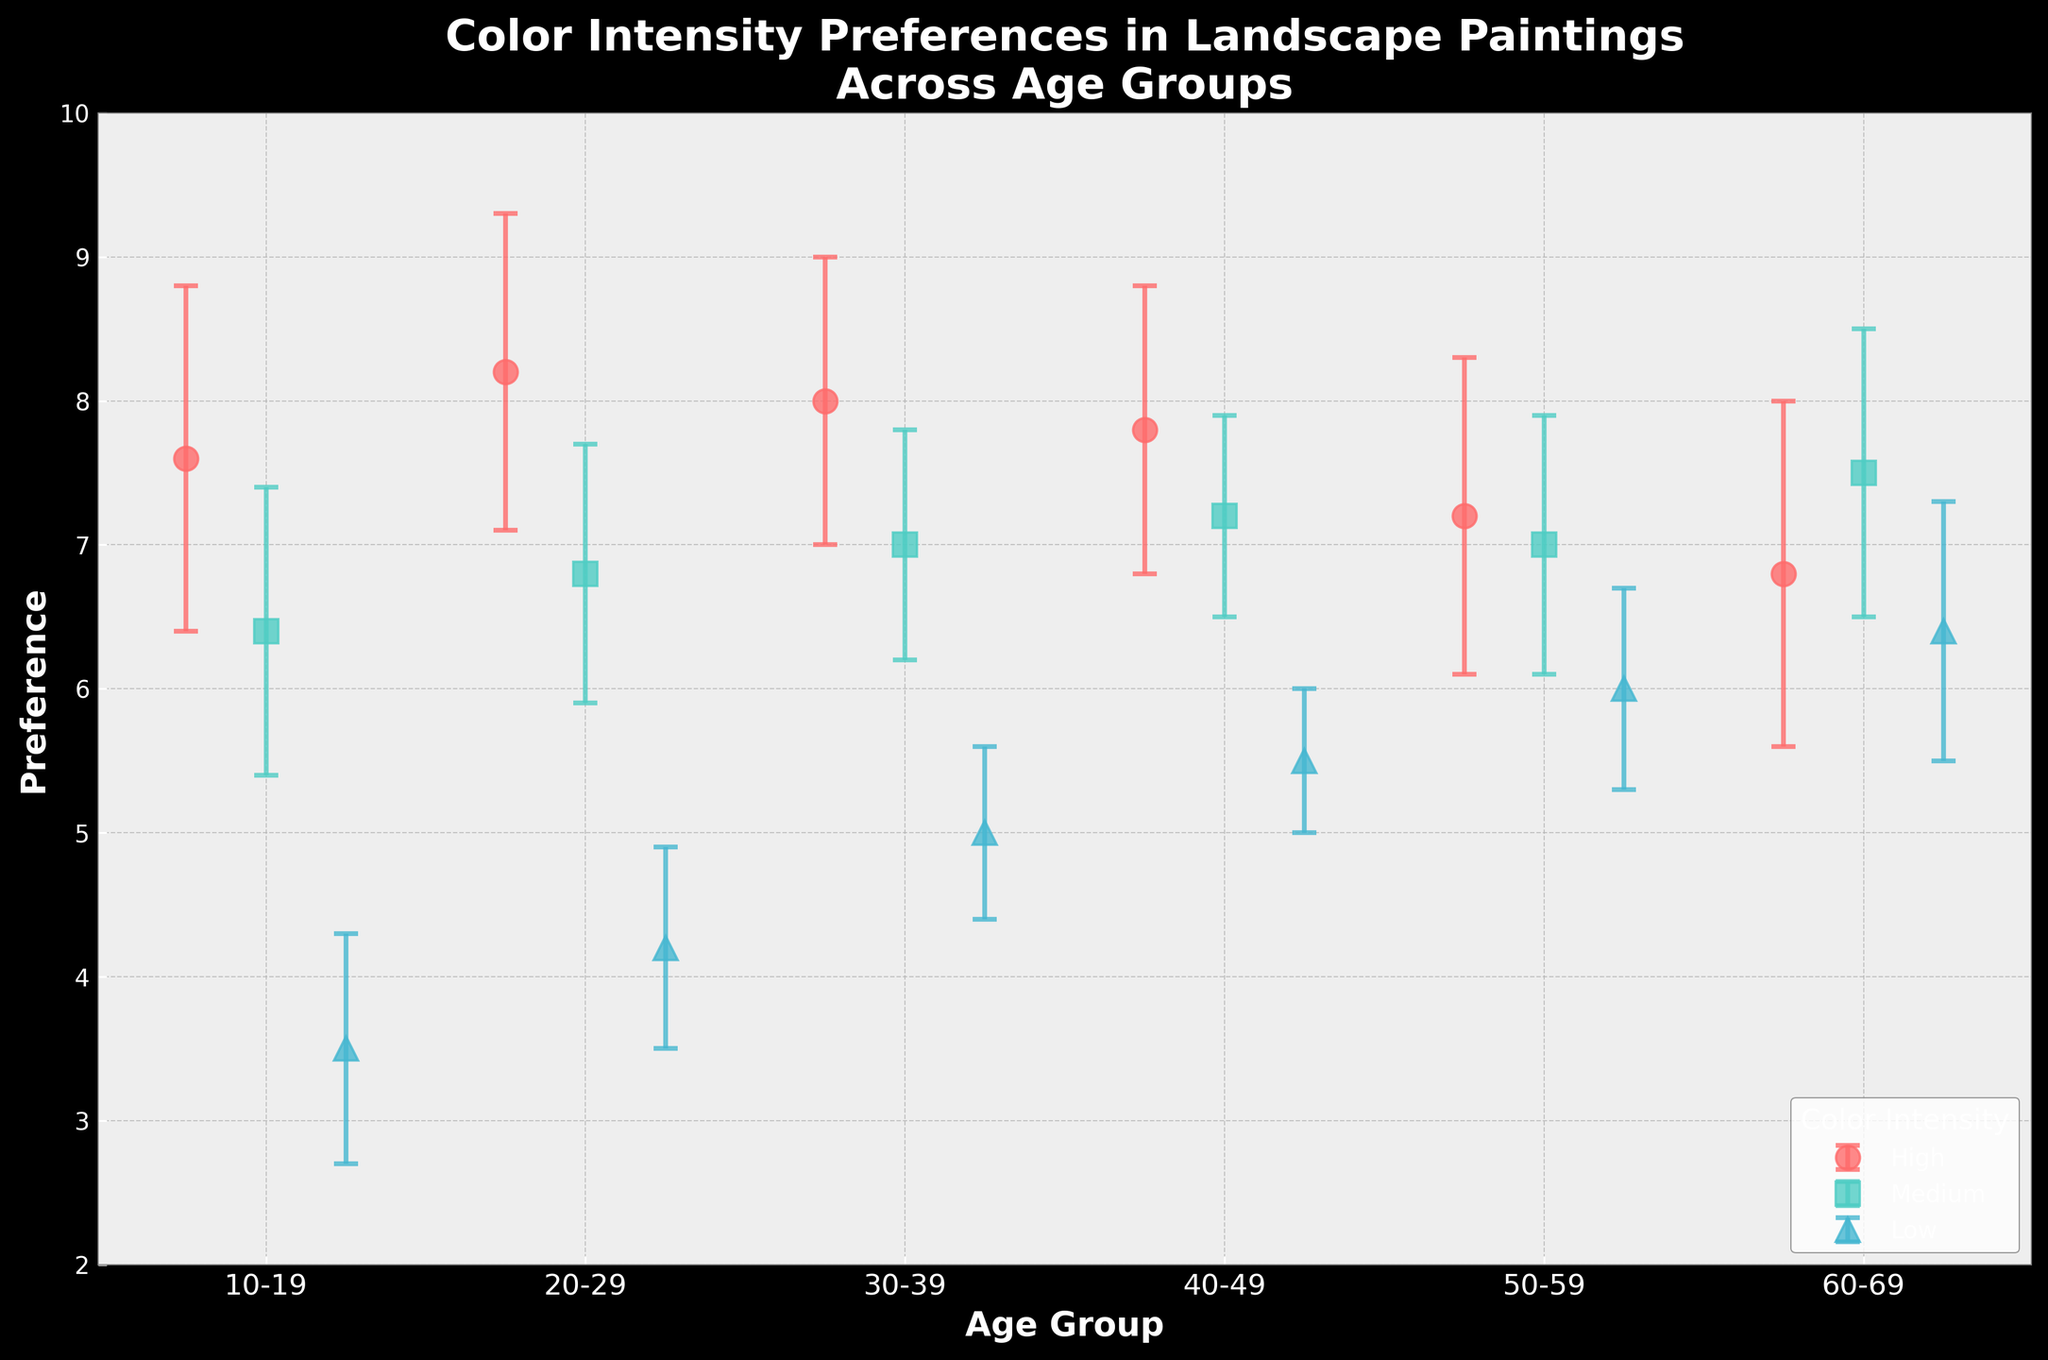What is the highest preference score for high color intensity? First, identify the preference scores for high color intensity. The values are 7.6, 8.2, 8.0, 7.8, 7.2, and 6.8. The highest among these is 8.2.
Answer: 8.2 What age group shows the lowest preference for low color intensity? Look at the preference scores for low color intensity across all age groups. The values are 3.5, 4.2, 5.0, 5.5, 6.0, and 6.4. The lowest value, 3.5, is seen in the 10-19 age group.
Answer: 10-19 Which age group has the greatest preference difference between high and low color intensity? Calculate the preference difference between high and low color intensity for each age group: 10-19 (7.6 - 3.5 = 4.1), 20-29 (8.2 - 4.2 = 4.0), 30-39 (8.0 - 5.0 = 3.0), 40-49 (7.8 - 5.5 = 2.3), 50-59 (7.2 - 6.0 = 1.2), 60-69 (6.8 - 6.4 = 0.4). The greatest difference is 4.1 in the 10-19 age group.
Answer: 10-19 In which age group is the preference for medium color intensity the highest? Compare the preference scores for medium color intensity across age groups: 10-19 (6.4), 20-29 (6.8), 30-39 (7.0), 40-49 (7.2), 50-59 (7.0), 60-69 (7.5). The highest is 7.5 in the 60-69 age group.
Answer: 60-69 What is the average preference for high color intensity across all age groups? Add the preference scores for high color intensity: 7.6, 8.2, 8.0, 7.8, 7.2, 6.8. The sum is 45.6. Divide by the number of age groups (6), so 45.6/6 ≈ 7.6.
Answer: 7.6 Which age group has the smallest standard deviation for medium color intensity? Compare the standard deviations: 10-19 (1.0), 20-29 (0.9), 30-39 (0.8), 40-49 (0.7), 50-59 (0.9), 60-69 (1.0). The smallest standard deviation, 0.7, occurs in the 40-49 age group.
Answer: 40-49 Is the preference for medium color intensity always lower than for high color intensity in all age groups? Compare the preference scores for each age group: 10-19 (6.4 < 7.6), 20-29 (6.8 < 8.2), 30-39 (7.0 < 8.0), 40-49 (7.2 < 7.8), 50-59 (7.0 < 7.2), 60-69 (7.5 > 6.8). In all but one age group (60-69), medium is lower than high.
Answer: No 